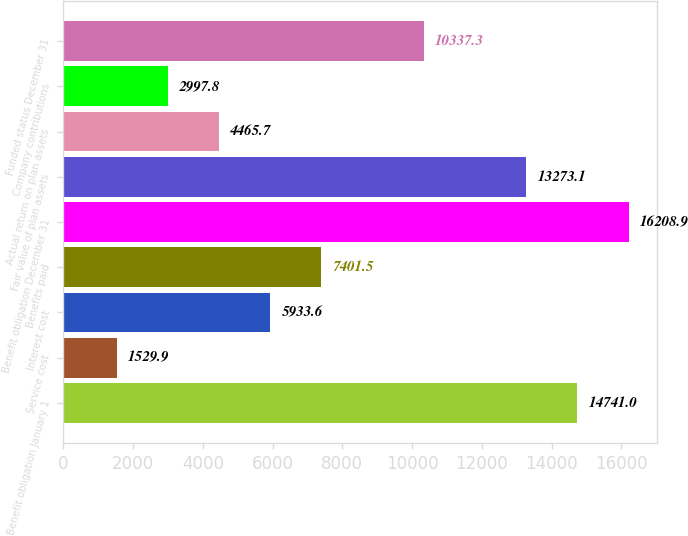Convert chart to OTSL. <chart><loc_0><loc_0><loc_500><loc_500><bar_chart><fcel>Benefit obligation January 1<fcel>Service cost<fcel>Interest cost<fcel>Benefits paid<fcel>Benefit obligation December 31<fcel>Fair value of plan assets<fcel>Actual return on plan assets<fcel>Company contributions<fcel>Funded status December 31<nl><fcel>14741<fcel>1529.9<fcel>5933.6<fcel>7401.5<fcel>16208.9<fcel>13273.1<fcel>4465.7<fcel>2997.8<fcel>10337.3<nl></chart> 